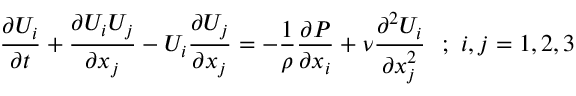Convert formula to latex. <formula><loc_0><loc_0><loc_500><loc_500>{ \frac { \partial U _ { i } } { \partial t } } + { \frac { \partial U _ { i } U _ { j } } { \partial x _ { j } } } - U _ { i } { \frac { \partial U _ { j } } { \partial x _ { j } } } = - { \frac { 1 } { \rho } } { \frac { \partial P } { \partial x _ { i } } } + \nu { \frac { \partial ^ { 2 } U _ { i } } { \partial x _ { j } ^ { 2 } } } ; i , j = 1 , 2 , 3</formula> 